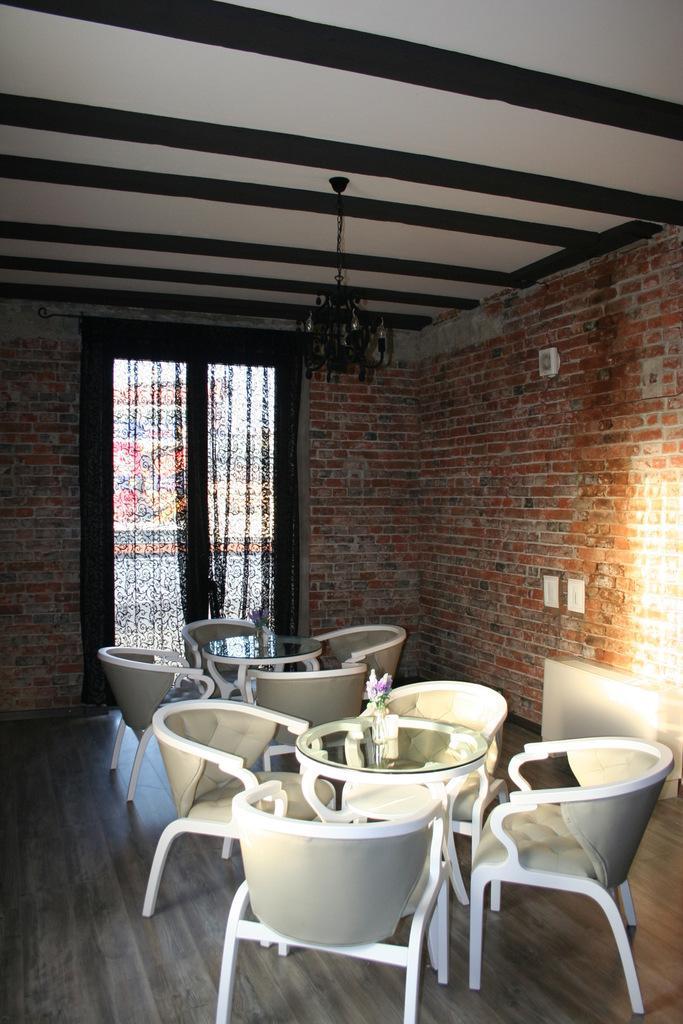In one or two sentences, can you explain what this image depicts? In this picture we can see tables and chairs on the floor, wall and in the background we can see a window with curtains. 